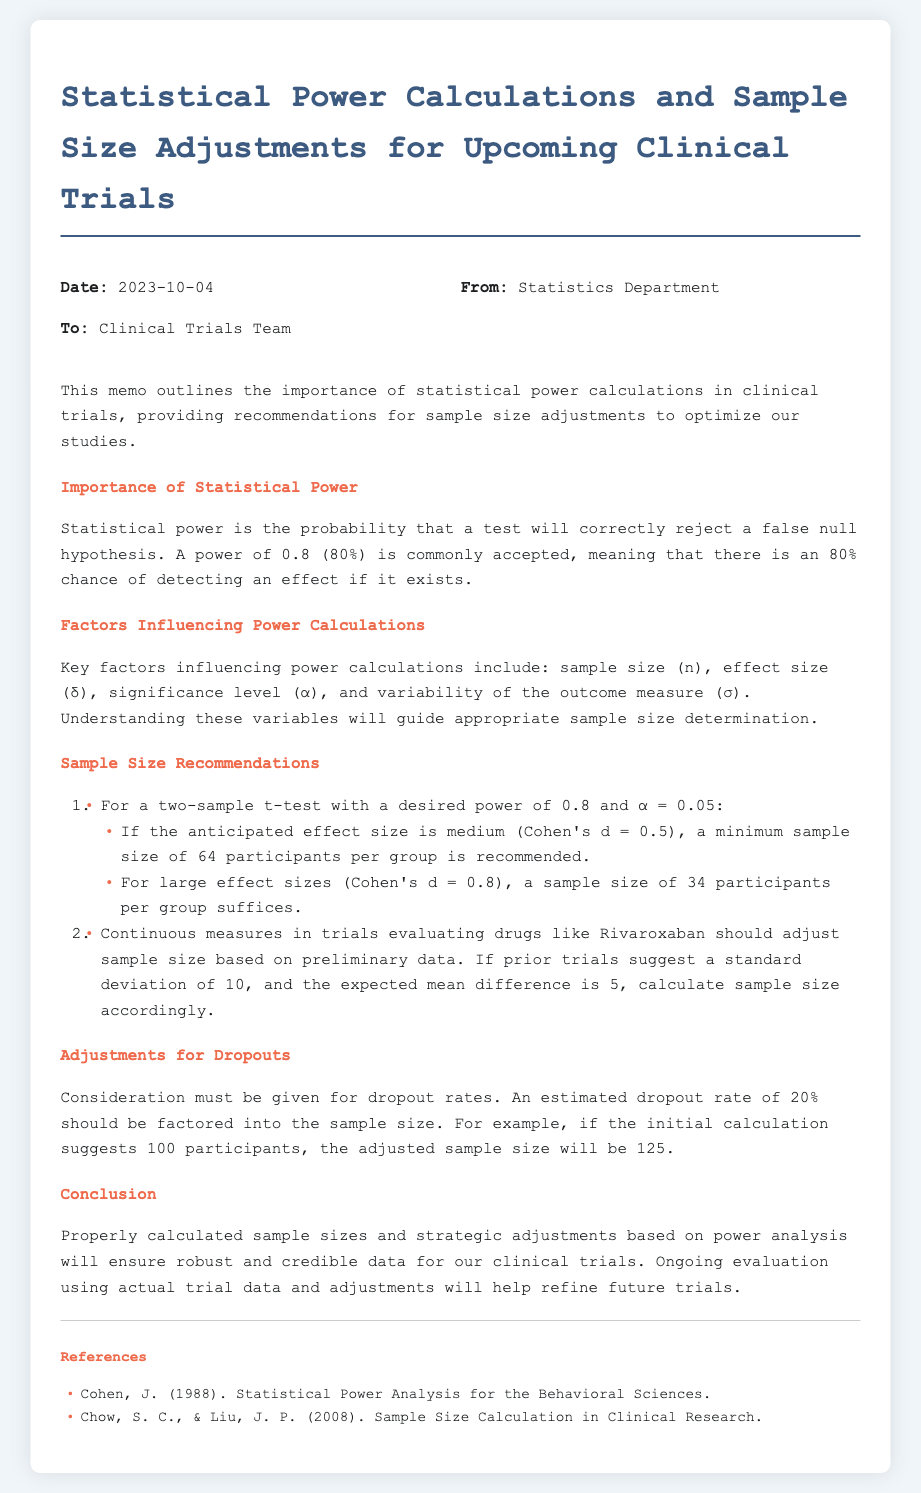What is the date of the memo? The date of the memo is stated in the header section.
Answer: 2023-10-04 Who is the memo addressed to? The memo specifies the recipient in the header section.
Answer: Clinical Trials Team What is the desired power level mentioned? The desired power level is discussed in the section on the Importance of Statistical Power.
Answer: 0.8 What is the recommended sample size for a medium effect size for a two-sample t-test? The memo lists the recommended sample sizes for effect sizes in the Sample Size Recommendations section.
Answer: 64 participants per group What is the estimated dropout rate mentioned? The dropout rate is noted in the Adjustments for Dropouts section.
Answer: 20% If the anticipated effect size is large (Cohen's d = 0.8), what is the sample size required per group? This information is provided in the Sample Size Recommendations section for large effect sizes.
Answer: 34 participants per group What does the memo suggest about adjustments based on dropout rates? The memo explains the adjustment process for dropouts in the Adjustments for Dropouts section.
Answer: An estimated dropout rate of 20% should be factored in What is the title of the memo? The title is prominently displayed at the top of the document.
Answer: Statistical Power Calculations and Sample Size Adjustments for Upcoming Clinical Trials What references are cited in the document? The memo lists references in a dedicated section towards the end.
Answer: Cohen, J. (1988). Statistical Power Analysis for the Behavioral Sciences. and Chow, S. C., & Liu, J. P. (2008). Sample Size Calculation in Clinical Research 